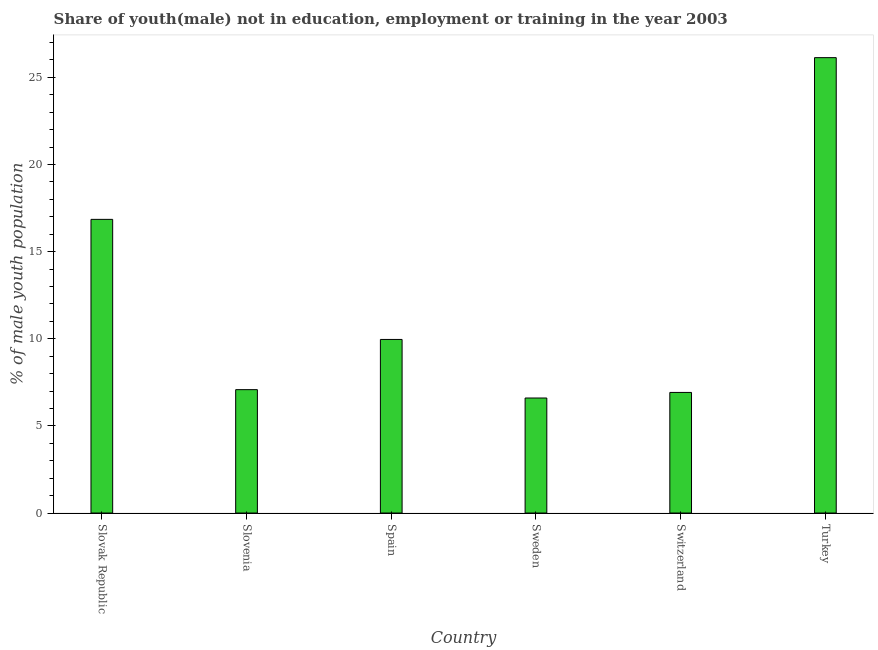What is the title of the graph?
Ensure brevity in your answer.  Share of youth(male) not in education, employment or training in the year 2003. What is the label or title of the Y-axis?
Give a very brief answer. % of male youth population. What is the unemployed male youth population in Spain?
Ensure brevity in your answer.  9.96. Across all countries, what is the maximum unemployed male youth population?
Provide a succinct answer. 26.13. Across all countries, what is the minimum unemployed male youth population?
Your answer should be very brief. 6.6. What is the sum of the unemployed male youth population?
Provide a short and direct response. 73.54. What is the difference between the unemployed male youth population in Slovenia and Spain?
Provide a short and direct response. -2.88. What is the average unemployed male youth population per country?
Provide a succinct answer. 12.26. What is the median unemployed male youth population?
Your answer should be very brief. 8.52. What is the ratio of the unemployed male youth population in Slovenia to that in Turkey?
Your response must be concise. 0.27. Is the difference between the unemployed male youth population in Spain and Turkey greater than the difference between any two countries?
Provide a short and direct response. No. What is the difference between the highest and the second highest unemployed male youth population?
Make the answer very short. 9.28. What is the difference between the highest and the lowest unemployed male youth population?
Your response must be concise. 19.53. How many bars are there?
Your answer should be very brief. 6. Are all the bars in the graph horizontal?
Your answer should be compact. No. How many countries are there in the graph?
Your answer should be compact. 6. Are the values on the major ticks of Y-axis written in scientific E-notation?
Your answer should be compact. No. What is the % of male youth population of Slovak Republic?
Offer a very short reply. 16.85. What is the % of male youth population in Slovenia?
Ensure brevity in your answer.  7.08. What is the % of male youth population of Spain?
Keep it short and to the point. 9.96. What is the % of male youth population of Sweden?
Your answer should be very brief. 6.6. What is the % of male youth population in Switzerland?
Your answer should be very brief. 6.92. What is the % of male youth population in Turkey?
Make the answer very short. 26.13. What is the difference between the % of male youth population in Slovak Republic and Slovenia?
Provide a short and direct response. 9.77. What is the difference between the % of male youth population in Slovak Republic and Spain?
Give a very brief answer. 6.89. What is the difference between the % of male youth population in Slovak Republic and Sweden?
Keep it short and to the point. 10.25. What is the difference between the % of male youth population in Slovak Republic and Switzerland?
Ensure brevity in your answer.  9.93. What is the difference between the % of male youth population in Slovak Republic and Turkey?
Provide a succinct answer. -9.28. What is the difference between the % of male youth population in Slovenia and Spain?
Ensure brevity in your answer.  -2.88. What is the difference between the % of male youth population in Slovenia and Sweden?
Keep it short and to the point. 0.48. What is the difference between the % of male youth population in Slovenia and Switzerland?
Your response must be concise. 0.16. What is the difference between the % of male youth population in Slovenia and Turkey?
Offer a very short reply. -19.05. What is the difference between the % of male youth population in Spain and Sweden?
Provide a short and direct response. 3.36. What is the difference between the % of male youth population in Spain and Switzerland?
Offer a terse response. 3.04. What is the difference between the % of male youth population in Spain and Turkey?
Provide a succinct answer. -16.17. What is the difference between the % of male youth population in Sweden and Switzerland?
Ensure brevity in your answer.  -0.32. What is the difference between the % of male youth population in Sweden and Turkey?
Your answer should be very brief. -19.53. What is the difference between the % of male youth population in Switzerland and Turkey?
Your answer should be compact. -19.21. What is the ratio of the % of male youth population in Slovak Republic to that in Slovenia?
Your answer should be compact. 2.38. What is the ratio of the % of male youth population in Slovak Republic to that in Spain?
Ensure brevity in your answer.  1.69. What is the ratio of the % of male youth population in Slovak Republic to that in Sweden?
Offer a very short reply. 2.55. What is the ratio of the % of male youth population in Slovak Republic to that in Switzerland?
Provide a short and direct response. 2.44. What is the ratio of the % of male youth population in Slovak Republic to that in Turkey?
Make the answer very short. 0.65. What is the ratio of the % of male youth population in Slovenia to that in Spain?
Your answer should be compact. 0.71. What is the ratio of the % of male youth population in Slovenia to that in Sweden?
Your answer should be compact. 1.07. What is the ratio of the % of male youth population in Slovenia to that in Switzerland?
Your response must be concise. 1.02. What is the ratio of the % of male youth population in Slovenia to that in Turkey?
Offer a terse response. 0.27. What is the ratio of the % of male youth population in Spain to that in Sweden?
Give a very brief answer. 1.51. What is the ratio of the % of male youth population in Spain to that in Switzerland?
Provide a short and direct response. 1.44. What is the ratio of the % of male youth population in Spain to that in Turkey?
Your answer should be very brief. 0.38. What is the ratio of the % of male youth population in Sweden to that in Switzerland?
Offer a very short reply. 0.95. What is the ratio of the % of male youth population in Sweden to that in Turkey?
Keep it short and to the point. 0.25. What is the ratio of the % of male youth population in Switzerland to that in Turkey?
Your response must be concise. 0.27. 